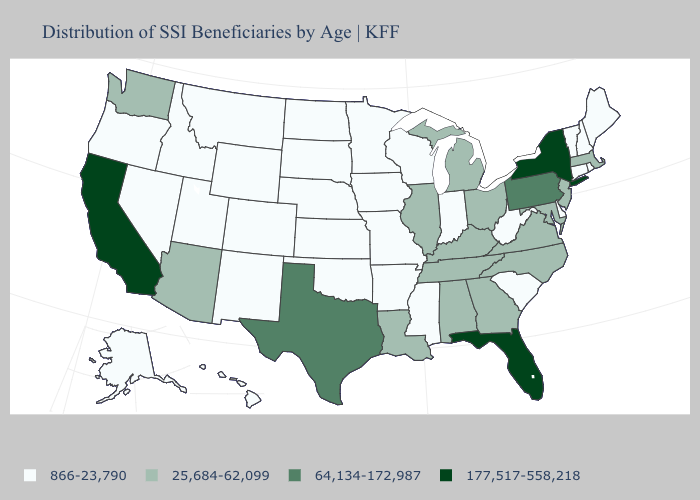Does the map have missing data?
Keep it brief. No. What is the highest value in the USA?
Short answer required. 177,517-558,218. Does California have the lowest value in the USA?
Be succinct. No. Which states hav the highest value in the West?
Short answer required. California. What is the value of Georgia?
Concise answer only. 25,684-62,099. Does Indiana have a higher value than Nebraska?
Keep it brief. No. Among the states that border Connecticut , does Rhode Island have the highest value?
Quick response, please. No. Does the map have missing data?
Keep it brief. No. Name the states that have a value in the range 64,134-172,987?
Answer briefly. Pennsylvania, Texas. Does Mississippi have a lower value than Michigan?
Concise answer only. Yes. What is the value of Idaho?
Concise answer only. 866-23,790. Name the states that have a value in the range 866-23,790?
Be succinct. Alaska, Arkansas, Colorado, Connecticut, Delaware, Hawaii, Idaho, Indiana, Iowa, Kansas, Maine, Minnesota, Mississippi, Missouri, Montana, Nebraska, Nevada, New Hampshire, New Mexico, North Dakota, Oklahoma, Oregon, Rhode Island, South Carolina, South Dakota, Utah, Vermont, West Virginia, Wisconsin, Wyoming. What is the value of Minnesota?
Keep it brief. 866-23,790. What is the value of Oklahoma?
Short answer required. 866-23,790. 